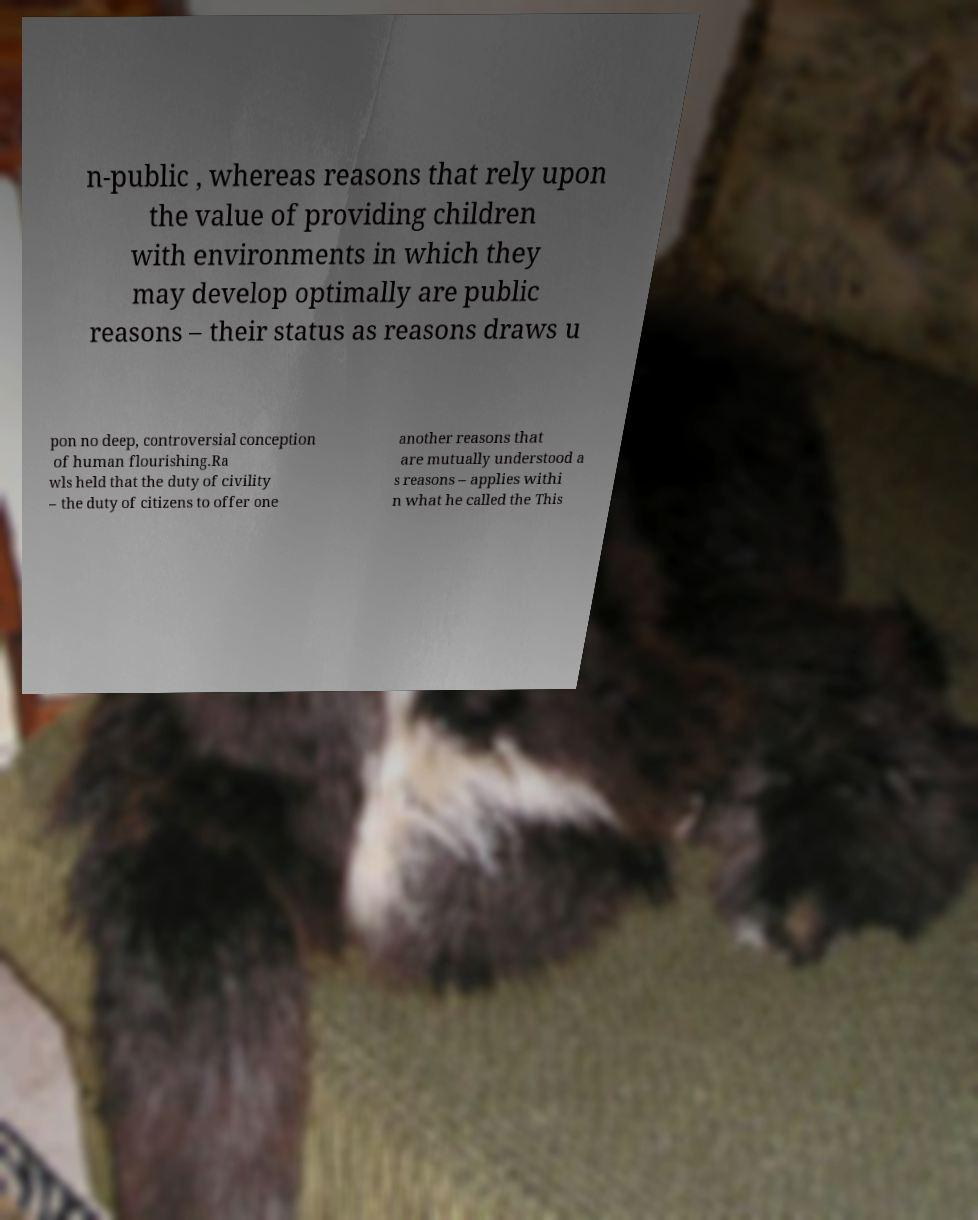There's text embedded in this image that I need extracted. Can you transcribe it verbatim? n-public , whereas reasons that rely upon the value of providing children with environments in which they may develop optimally are public reasons – their status as reasons draws u pon no deep, controversial conception of human flourishing.Ra wls held that the duty of civility – the duty of citizens to offer one another reasons that are mutually understood a s reasons – applies withi n what he called the This 